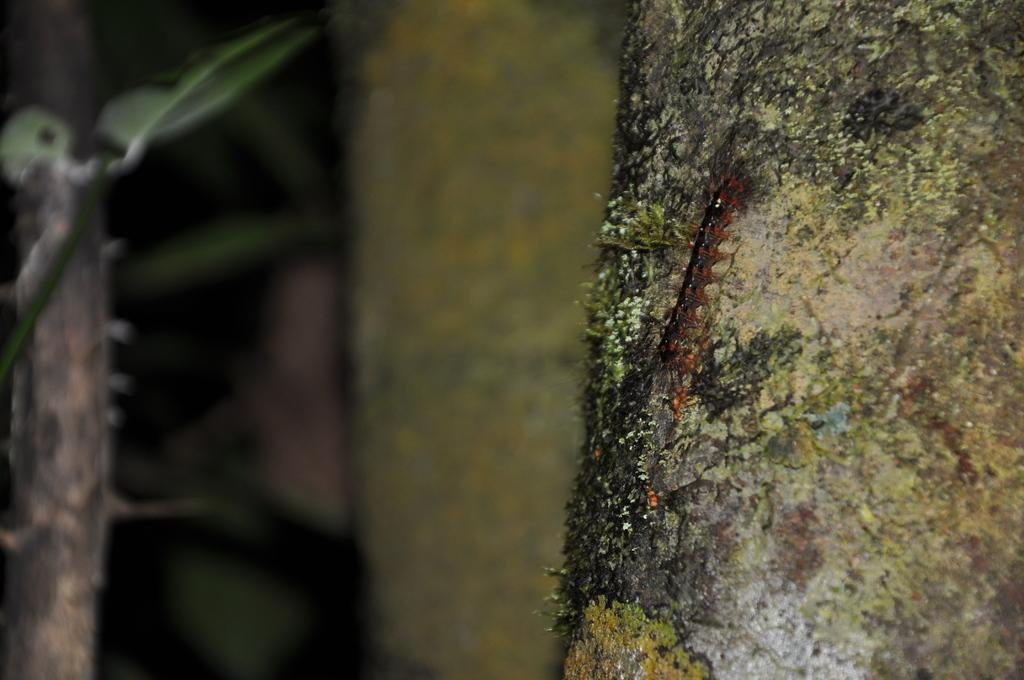What object is the main focus of the image? There is a trunk in the image. Is there anything else present on the trunk? Yes, there is an insect on the trunk. Can you describe the background of the image? The background of the image is blurred. What type of wrench is being used to fix the detail on the trunk in the image? There is no wrench present in the image, nor is there any detail being fixed on the trunk. 